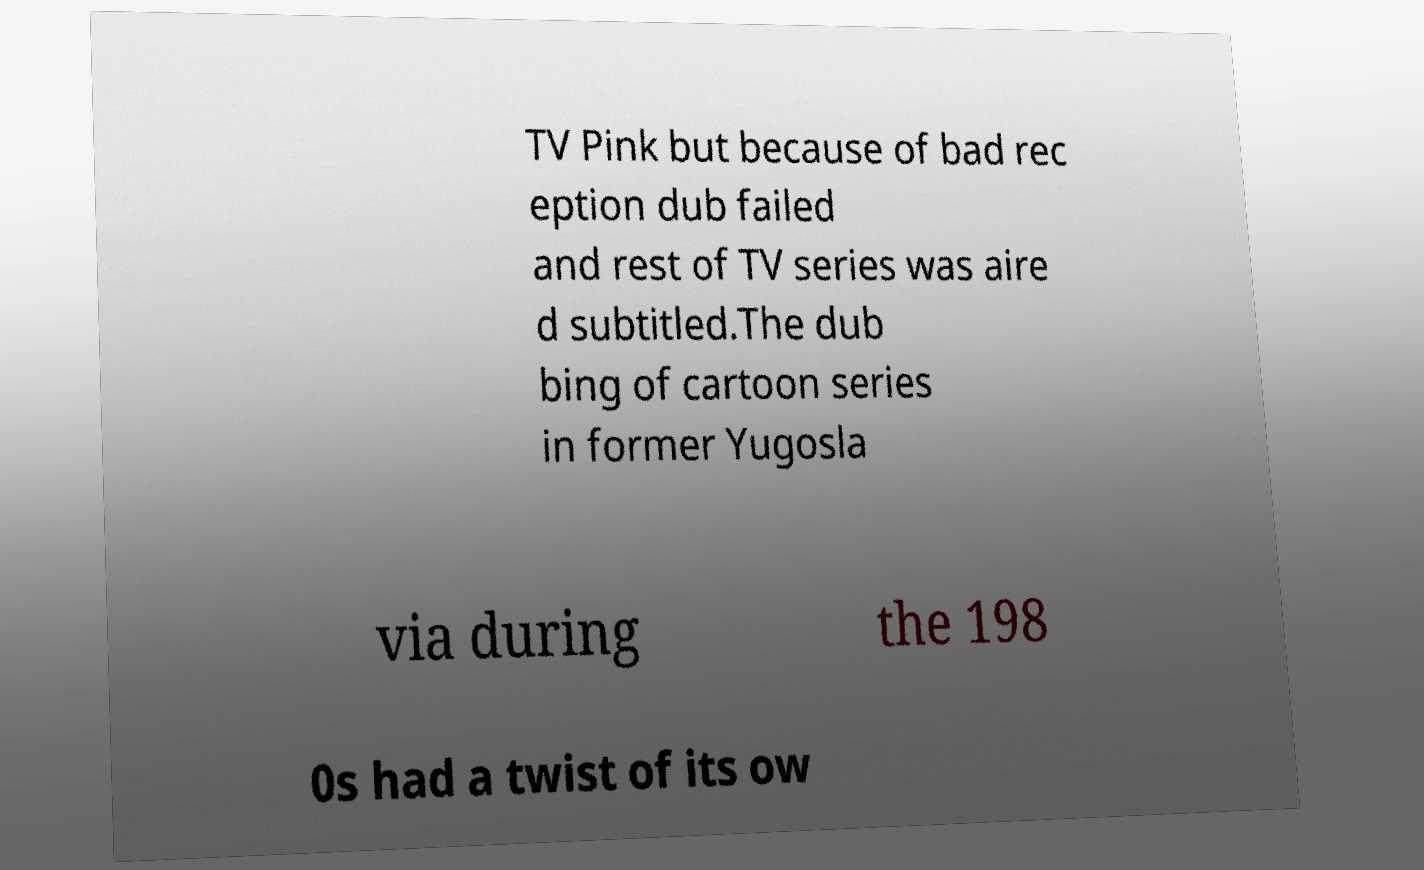What messages or text are displayed in this image? I need them in a readable, typed format. TV Pink but because of bad rec eption dub failed and rest of TV series was aire d subtitled.The dub bing of cartoon series in former Yugosla via during the 198 0s had a twist of its ow 